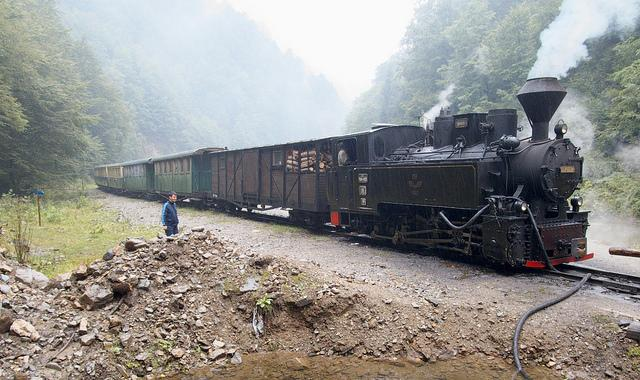What is being used to maintain the steam engine's momentum? Please explain your reasoning. wood. Logs are stacked in the car behind the engine. 